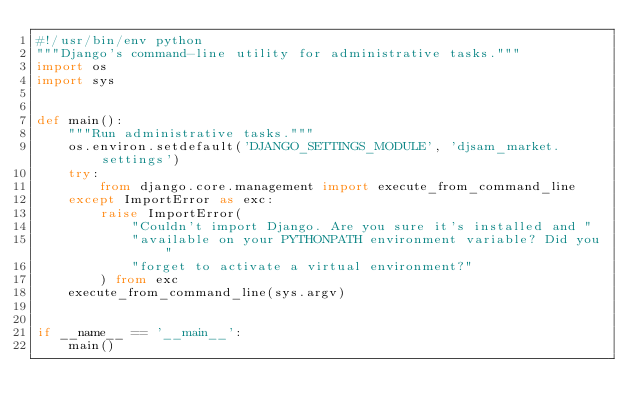<code> <loc_0><loc_0><loc_500><loc_500><_Python_>#!/usr/bin/env python
"""Django's command-line utility for administrative tasks."""
import os
import sys


def main():
    """Run administrative tasks."""
    os.environ.setdefault('DJANGO_SETTINGS_MODULE', 'djsam_market.settings')
    try:
        from django.core.management import execute_from_command_line
    except ImportError as exc:
        raise ImportError(
            "Couldn't import Django. Are you sure it's installed and "
            "available on your PYTHONPATH environment variable? Did you "
            "forget to activate a virtual environment?"
        ) from exc
    execute_from_command_line(sys.argv)


if __name__ == '__main__':
    main()
</code> 